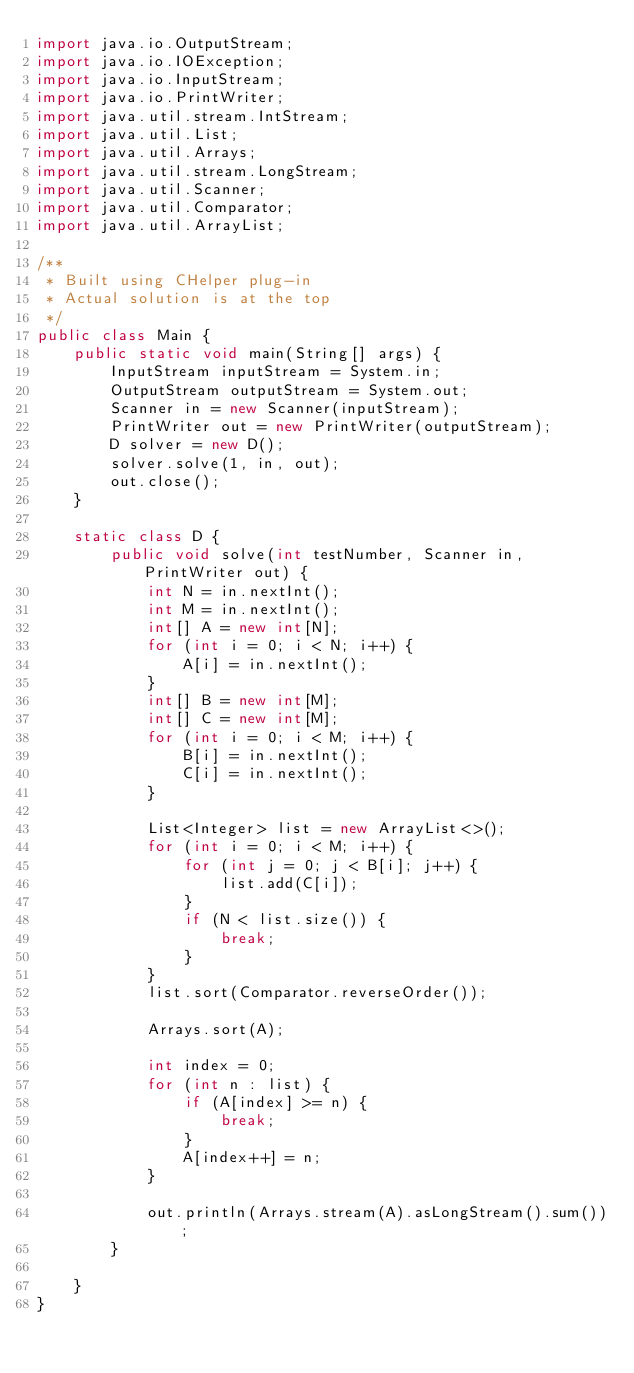Convert code to text. <code><loc_0><loc_0><loc_500><loc_500><_Java_>import java.io.OutputStream;
import java.io.IOException;
import java.io.InputStream;
import java.io.PrintWriter;
import java.util.stream.IntStream;
import java.util.List;
import java.util.Arrays;
import java.util.stream.LongStream;
import java.util.Scanner;
import java.util.Comparator;
import java.util.ArrayList;

/**
 * Built using CHelper plug-in
 * Actual solution is at the top
 */
public class Main {
    public static void main(String[] args) {
        InputStream inputStream = System.in;
        OutputStream outputStream = System.out;
        Scanner in = new Scanner(inputStream);
        PrintWriter out = new PrintWriter(outputStream);
        D solver = new D();
        solver.solve(1, in, out);
        out.close();
    }

    static class D {
        public void solve(int testNumber, Scanner in, PrintWriter out) {
            int N = in.nextInt();
            int M = in.nextInt();
            int[] A = new int[N];
            for (int i = 0; i < N; i++) {
                A[i] = in.nextInt();
            }
            int[] B = new int[M];
            int[] C = new int[M];
            for (int i = 0; i < M; i++) {
                B[i] = in.nextInt();
                C[i] = in.nextInt();
            }

            List<Integer> list = new ArrayList<>();
            for (int i = 0; i < M; i++) {
                for (int j = 0; j < B[i]; j++) {
                    list.add(C[i]);
                }
                if (N < list.size()) {
                    break;
                }
            }
            list.sort(Comparator.reverseOrder());

            Arrays.sort(A);

            int index = 0;
            for (int n : list) {
                if (A[index] >= n) {
                    break;
                }
                A[index++] = n;
            }

            out.println(Arrays.stream(A).asLongStream().sum());
        }

    }
}

</code> 